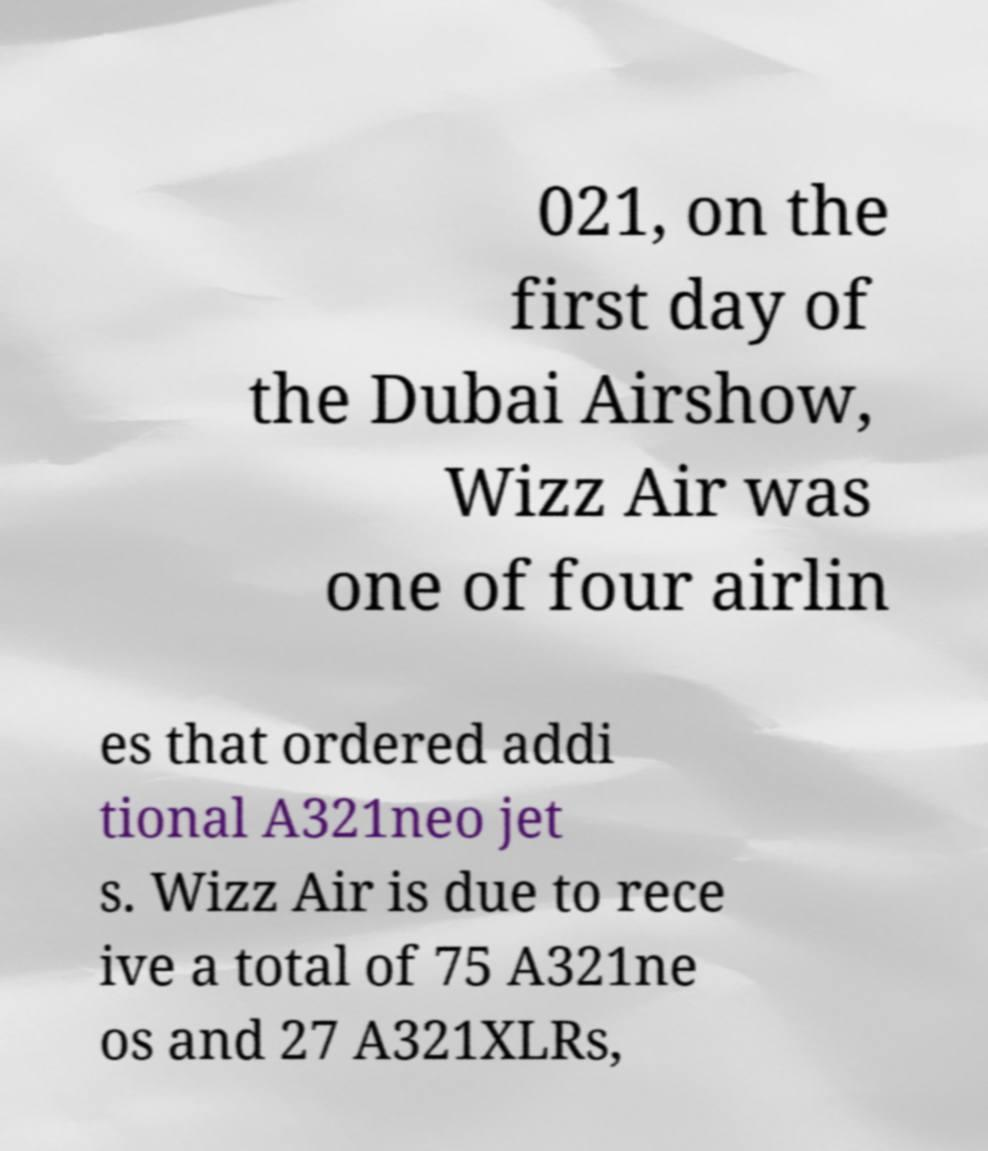Can you accurately transcribe the text from the provided image for me? 021, on the first day of the Dubai Airshow, Wizz Air was one of four airlin es that ordered addi tional A321neo jet s. Wizz Air is due to rece ive a total of 75 A321ne os and 27 A321XLRs, 